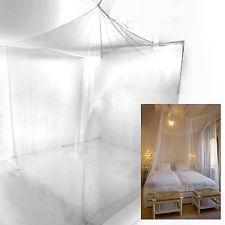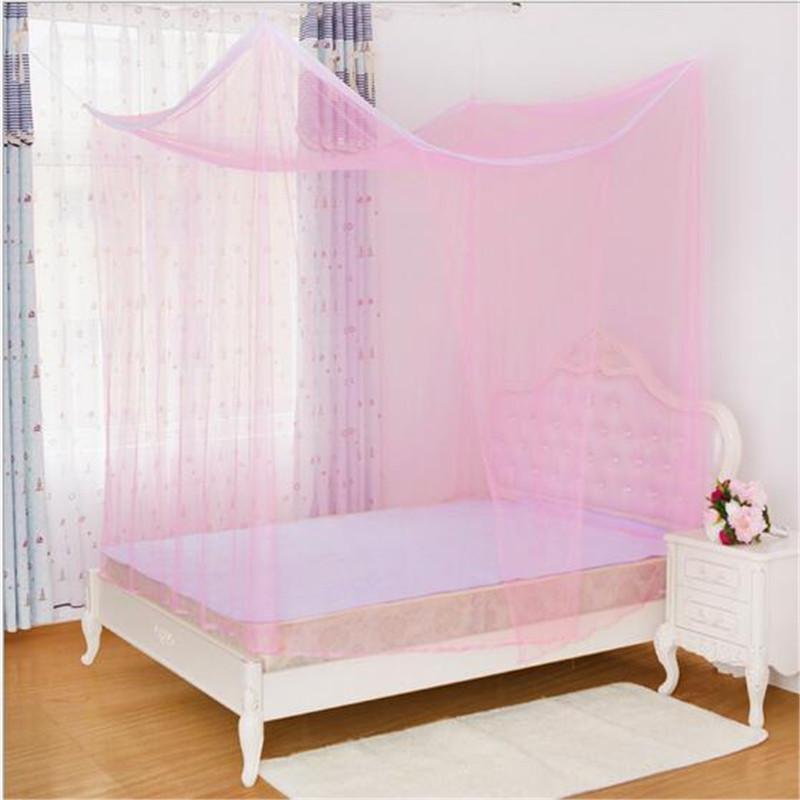The first image is the image on the left, the second image is the image on the right. Evaluate the accuracy of this statement regarding the images: "A bed with its pillow on the left and a cloth-covered table alongside it has a canopy with each corner lifted by a strap.". Is it true? Answer yes or no. No. 